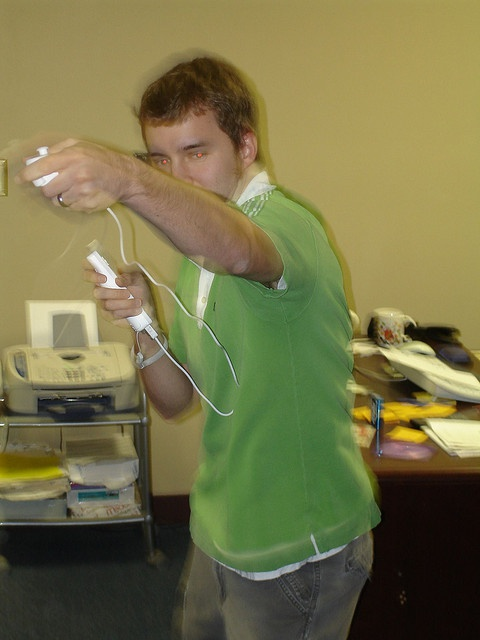Describe the objects in this image and their specific colors. I can see people in olive, darkgreen, green, and tan tones, cup in olive, tan, and black tones, remote in olive, lightgray, and darkgray tones, and remote in olive, lightgray, darkgray, and gray tones in this image. 